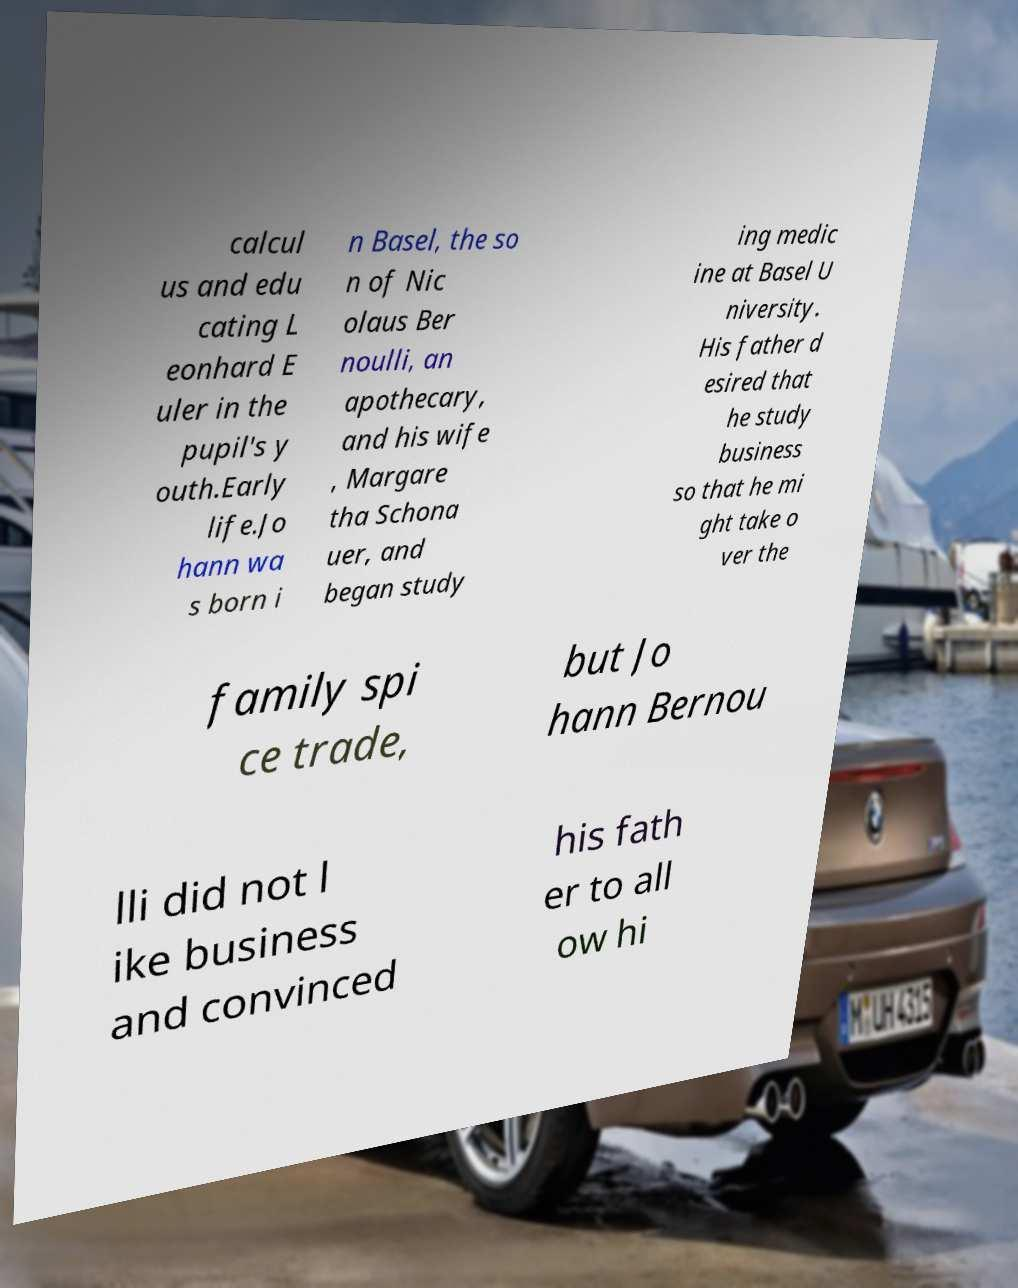For documentation purposes, I need the text within this image transcribed. Could you provide that? calcul us and edu cating L eonhard E uler in the pupil's y outh.Early life.Jo hann wa s born i n Basel, the so n of Nic olaus Ber noulli, an apothecary, and his wife , Margare tha Schona uer, and began study ing medic ine at Basel U niversity. His father d esired that he study business so that he mi ght take o ver the family spi ce trade, but Jo hann Bernou lli did not l ike business and convinced his fath er to all ow hi 